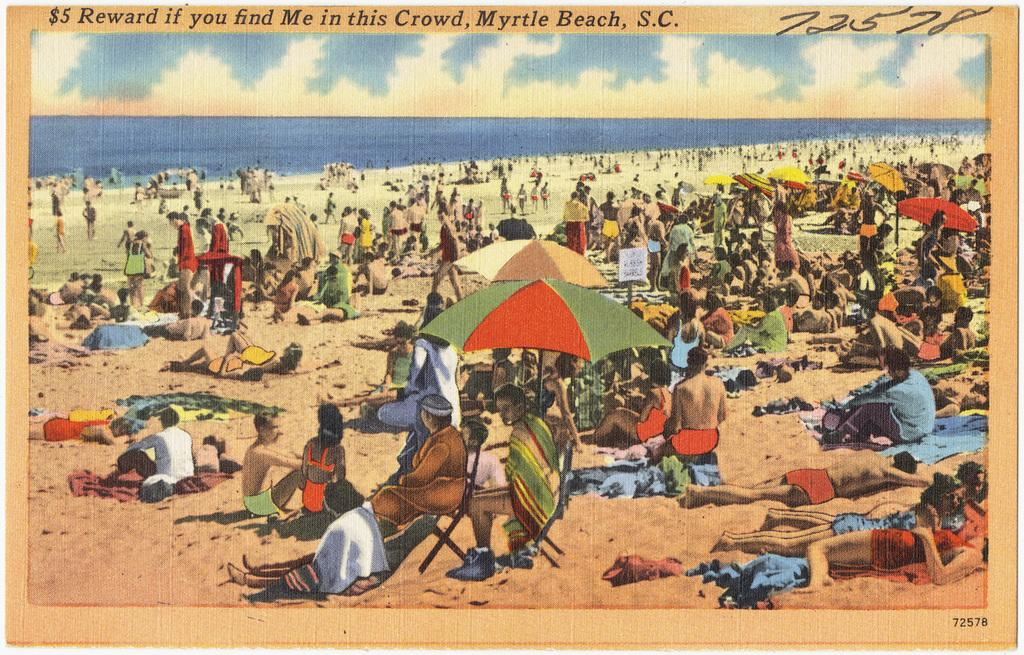Provide a one-sentence caption for the provided image. old photo of myrtle beach that offers five dollar reward if you find a certain person. 